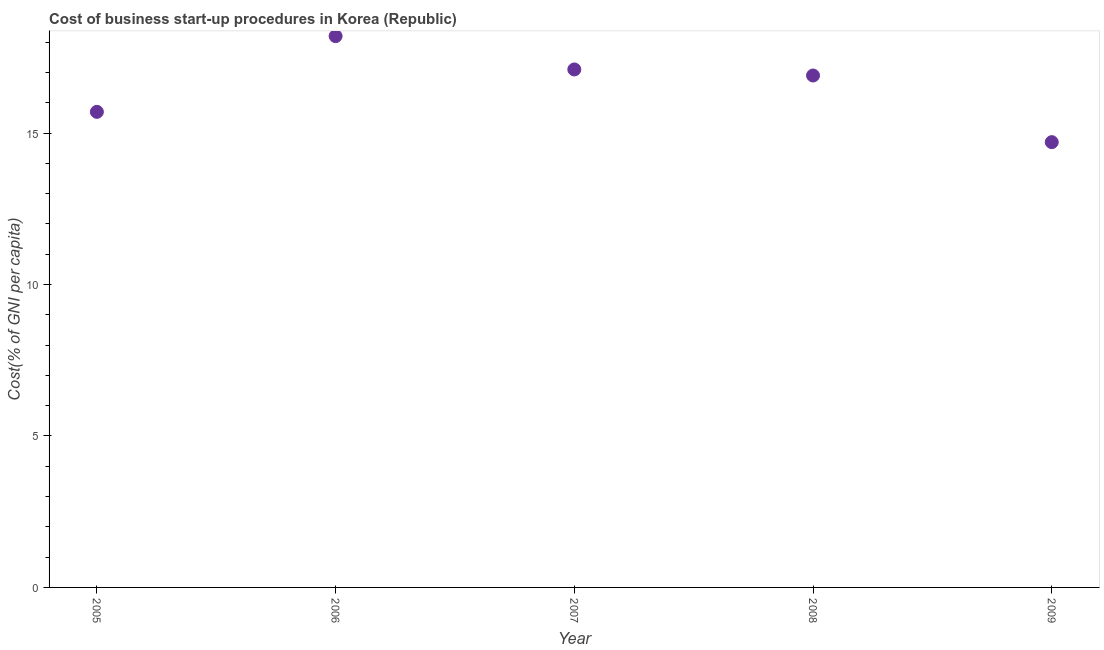Across all years, what is the maximum cost of business startup procedures?
Offer a terse response. 18.2. In which year was the cost of business startup procedures minimum?
Your answer should be very brief. 2009. What is the sum of the cost of business startup procedures?
Keep it short and to the point. 82.6. What is the difference between the cost of business startup procedures in 2007 and 2009?
Make the answer very short. 2.4. What is the average cost of business startup procedures per year?
Your answer should be compact. 16.52. In how many years, is the cost of business startup procedures greater than 14 %?
Your response must be concise. 5. Do a majority of the years between 2006 and 2005 (inclusive) have cost of business startup procedures greater than 4 %?
Offer a terse response. No. What is the ratio of the cost of business startup procedures in 2008 to that in 2009?
Your answer should be very brief. 1.15. What is the difference between the highest and the second highest cost of business startup procedures?
Your response must be concise. 1.1. How many years are there in the graph?
Offer a terse response. 5. Does the graph contain any zero values?
Provide a succinct answer. No. What is the title of the graph?
Keep it short and to the point. Cost of business start-up procedures in Korea (Republic). What is the label or title of the Y-axis?
Your answer should be very brief. Cost(% of GNI per capita). What is the Cost(% of GNI per capita) in 2006?
Your answer should be compact. 18.2. What is the Cost(% of GNI per capita) in 2008?
Your response must be concise. 16.9. What is the Cost(% of GNI per capita) in 2009?
Keep it short and to the point. 14.7. What is the difference between the Cost(% of GNI per capita) in 2005 and 2006?
Your answer should be compact. -2.5. What is the difference between the Cost(% of GNI per capita) in 2005 and 2007?
Make the answer very short. -1.4. What is the difference between the Cost(% of GNI per capita) in 2005 and 2009?
Offer a very short reply. 1. What is the difference between the Cost(% of GNI per capita) in 2006 and 2008?
Provide a short and direct response. 1.3. What is the difference between the Cost(% of GNI per capita) in 2007 and 2009?
Your answer should be very brief. 2.4. What is the ratio of the Cost(% of GNI per capita) in 2005 to that in 2006?
Provide a succinct answer. 0.86. What is the ratio of the Cost(% of GNI per capita) in 2005 to that in 2007?
Your answer should be compact. 0.92. What is the ratio of the Cost(% of GNI per capita) in 2005 to that in 2008?
Your answer should be very brief. 0.93. What is the ratio of the Cost(% of GNI per capita) in 2005 to that in 2009?
Your answer should be compact. 1.07. What is the ratio of the Cost(% of GNI per capita) in 2006 to that in 2007?
Offer a very short reply. 1.06. What is the ratio of the Cost(% of GNI per capita) in 2006 to that in 2008?
Make the answer very short. 1.08. What is the ratio of the Cost(% of GNI per capita) in 2006 to that in 2009?
Your answer should be very brief. 1.24. What is the ratio of the Cost(% of GNI per capita) in 2007 to that in 2008?
Your response must be concise. 1.01. What is the ratio of the Cost(% of GNI per capita) in 2007 to that in 2009?
Your answer should be very brief. 1.16. What is the ratio of the Cost(% of GNI per capita) in 2008 to that in 2009?
Keep it short and to the point. 1.15. 